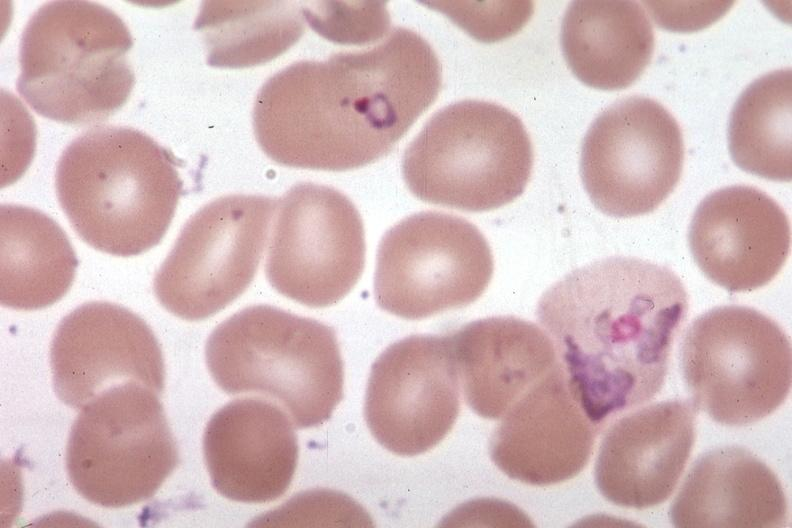s malaria plasmodium vivax present?
Answer the question using a single word or phrase. Yes 